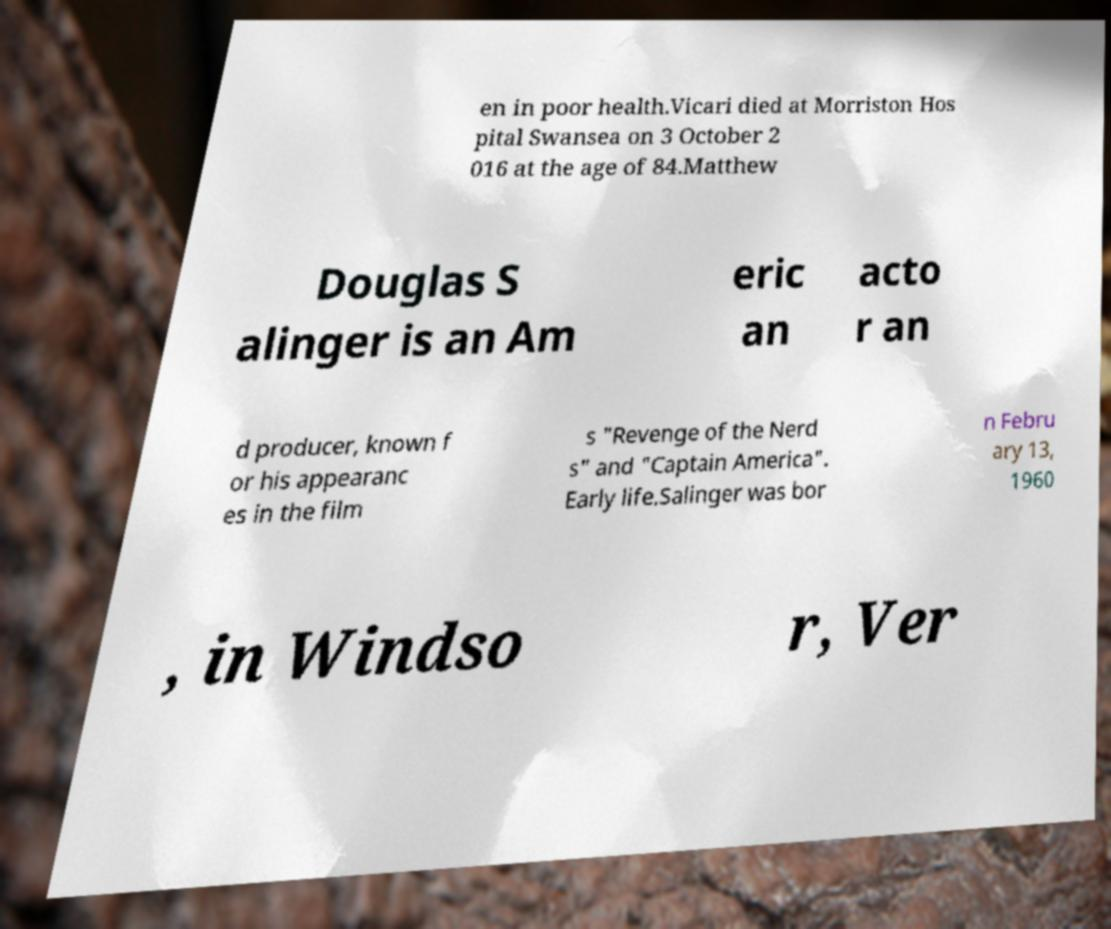Please read and relay the text visible in this image. What does it say? en in poor health.Vicari died at Morriston Hos pital Swansea on 3 October 2 016 at the age of 84.Matthew Douglas S alinger is an Am eric an acto r an d producer, known f or his appearanc es in the film s "Revenge of the Nerd s" and "Captain America". Early life.Salinger was bor n Febru ary 13, 1960 , in Windso r, Ver 